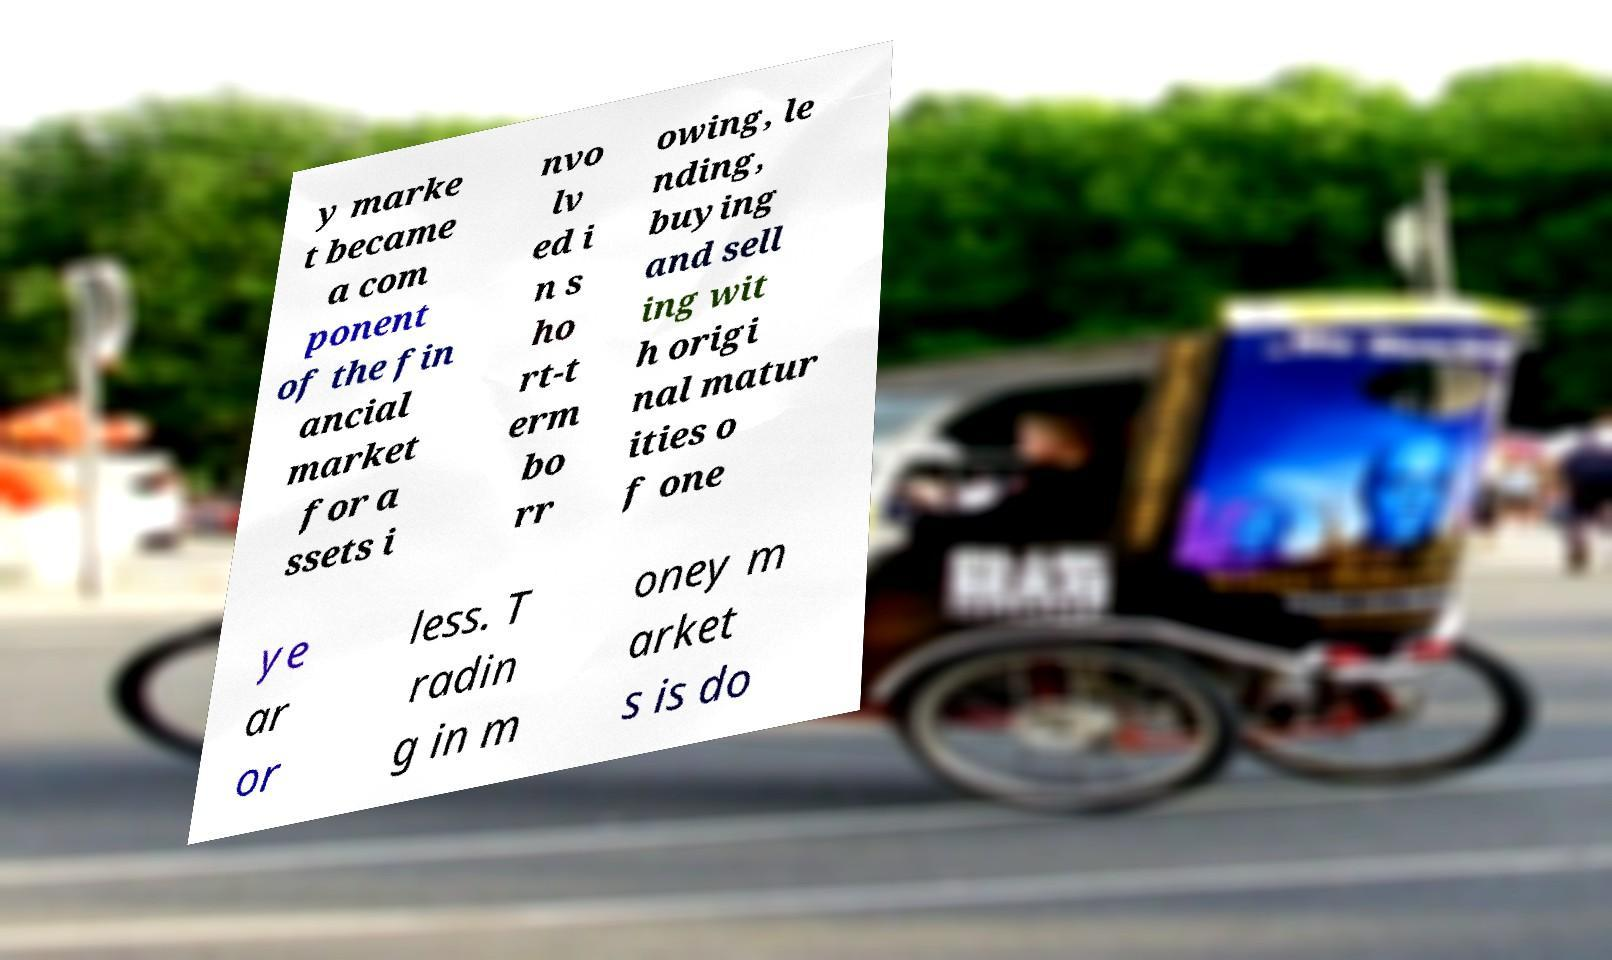What messages or text are displayed in this image? I need them in a readable, typed format. y marke t became a com ponent of the fin ancial market for a ssets i nvo lv ed i n s ho rt-t erm bo rr owing, le nding, buying and sell ing wit h origi nal matur ities o f one ye ar or less. T radin g in m oney m arket s is do 